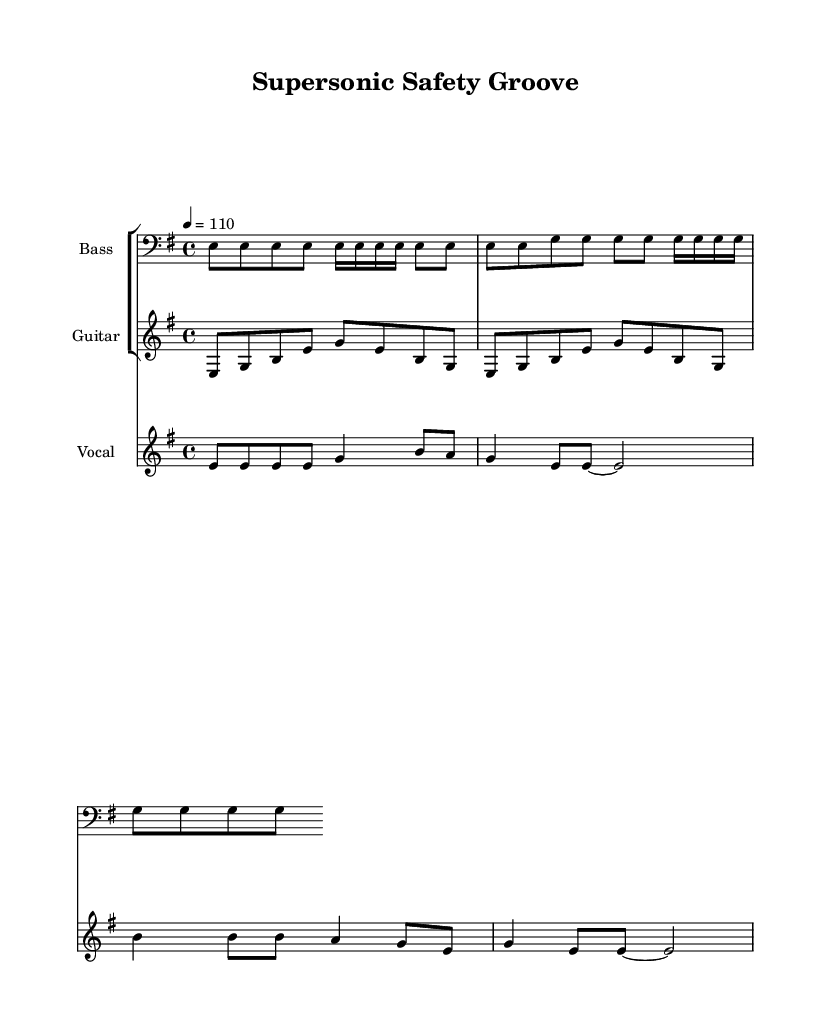What is the key signature of this music? The key signature is indicated at the beginning of the staff. In this score, it shows one sharp sign, which denotes E minor.
Answer: E minor What is the time signature of the piece? The time signature is located at the beginning of the score, indicated by the fraction. In this case, it is 4/4, meaning there are four beats per measure and the quarter note gets one beat.
Answer: 4/4 What is the tempo marking for this piece? The tempo marking can be found above the staff, which indicates how fast the piece should be played. In this score, it is marked as 4 = 110, suggesting a tempo of 110 beats per minute.
Answer: 110 How many measures does the vocal melody have? The vocal melody section is represented in two lines. Counting the distinct bars in the vocal melody, we see it consists of a total of 5 measures.
Answer: 5 What emotional theme is expressed in the lyrics? Analyzing the lyrics reveals the theme revolves around safety duties in aviation inspections, emphasizing responsibility and vigilance. The lyrics reflect a commitment to maintaining safety standards.
Answer: Safety What instrumentation is used in this piece? The instrumentation can be determined by looking at the staff names at the beginning of each staff line. This score features bass, guitar, and vocals, showcasing a lively funk ensemble.
Answer: Bass, Guitar, Vocals What is the prominent groove style of this composition? The groove style is assessed through the rhythmic patterns and feel found in the bass and guitar lines. The syncopated rhythm combined with a steady backbeat indicates a funky groove, typical of funk music.
Answer: Funky groove 